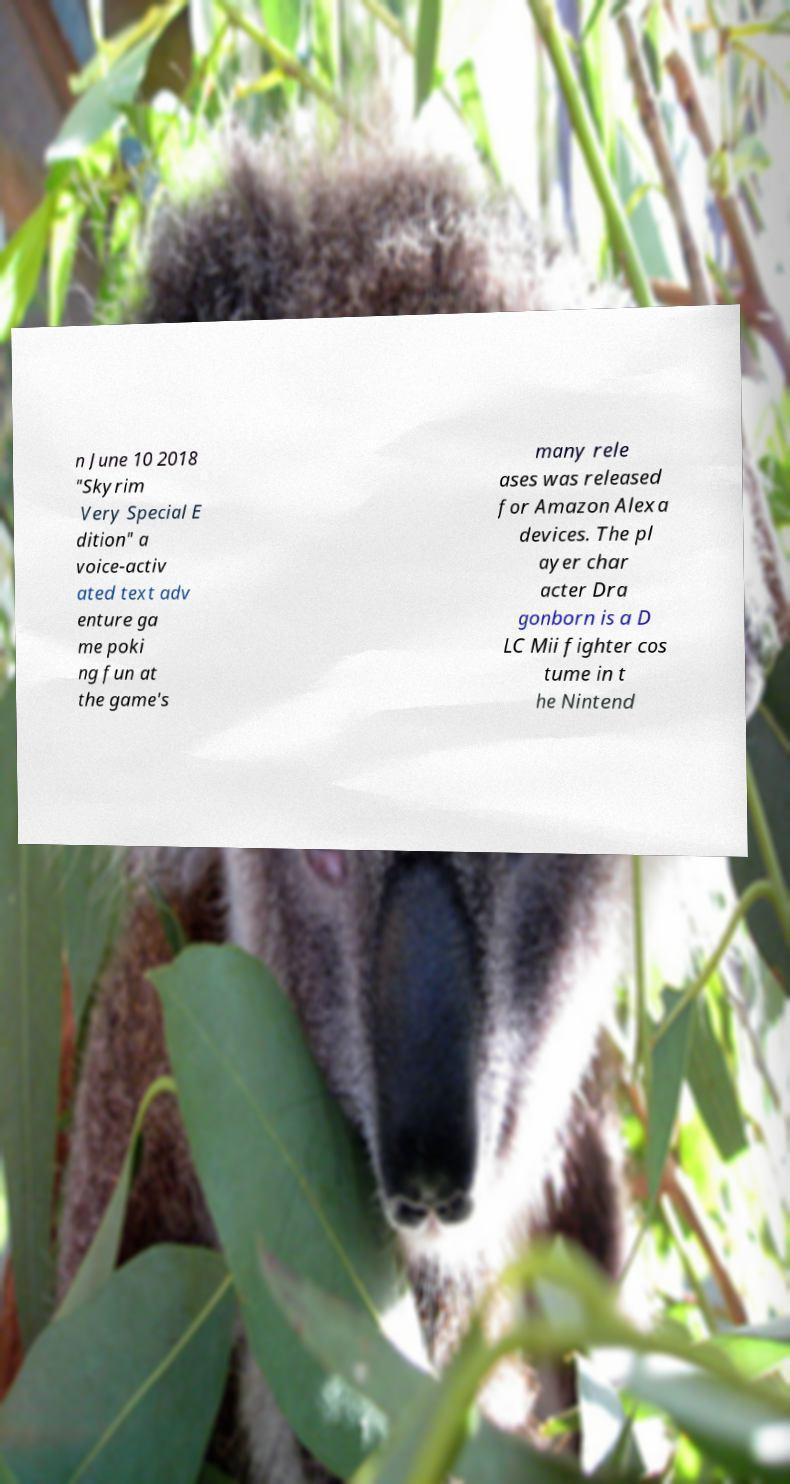Could you extract and type out the text from this image? n June 10 2018 "Skyrim Very Special E dition" a voice-activ ated text adv enture ga me poki ng fun at the game's many rele ases was released for Amazon Alexa devices. The pl ayer char acter Dra gonborn is a D LC Mii fighter cos tume in t he Nintend 